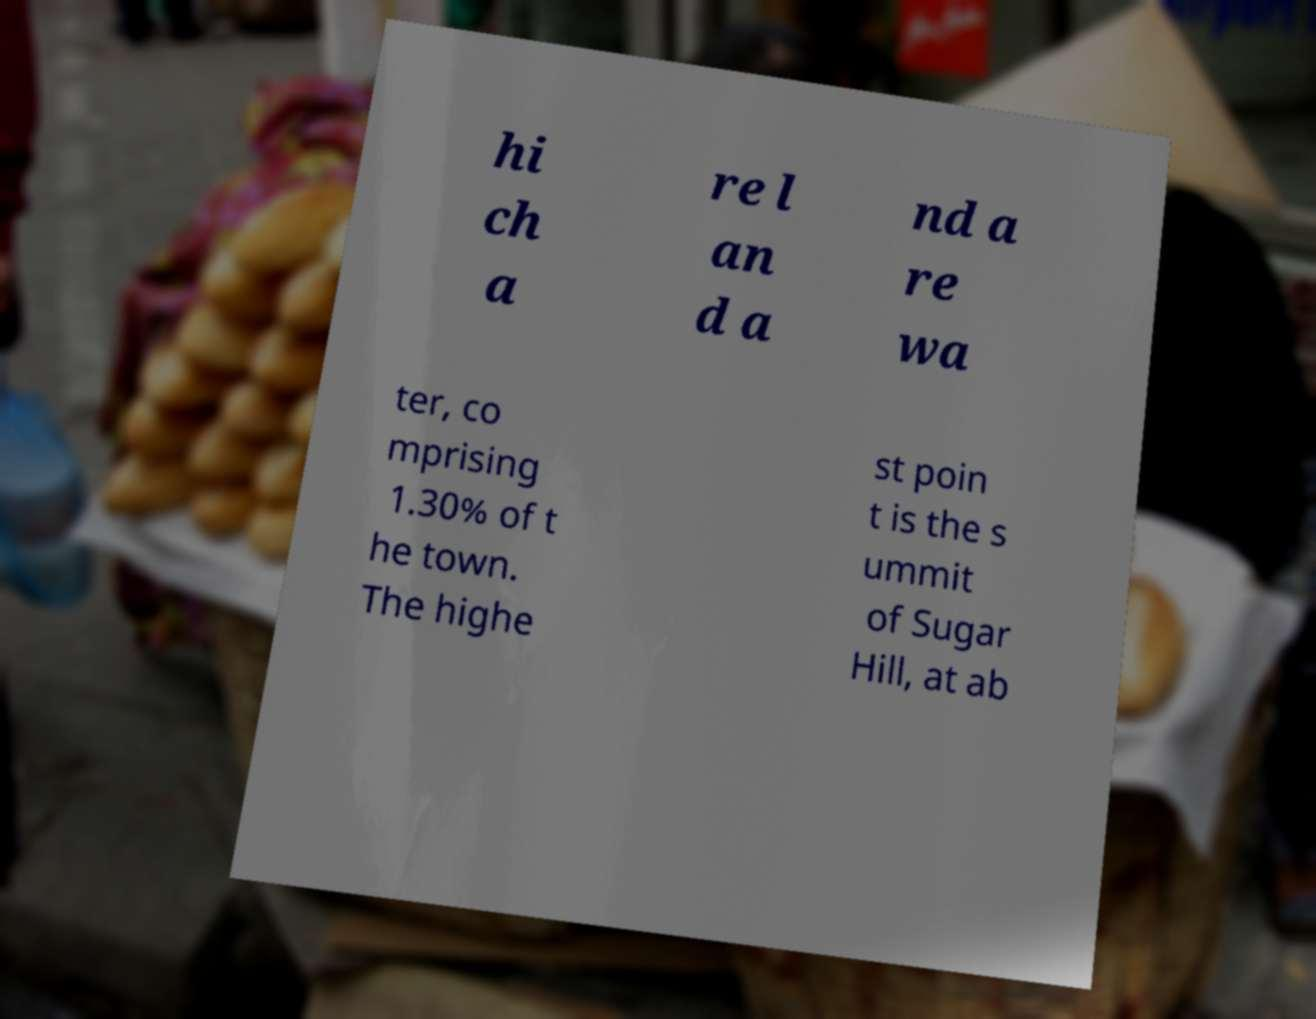There's text embedded in this image that I need extracted. Can you transcribe it verbatim? hi ch a re l an d a nd a re wa ter, co mprising 1.30% of t he town. The highe st poin t is the s ummit of Sugar Hill, at ab 